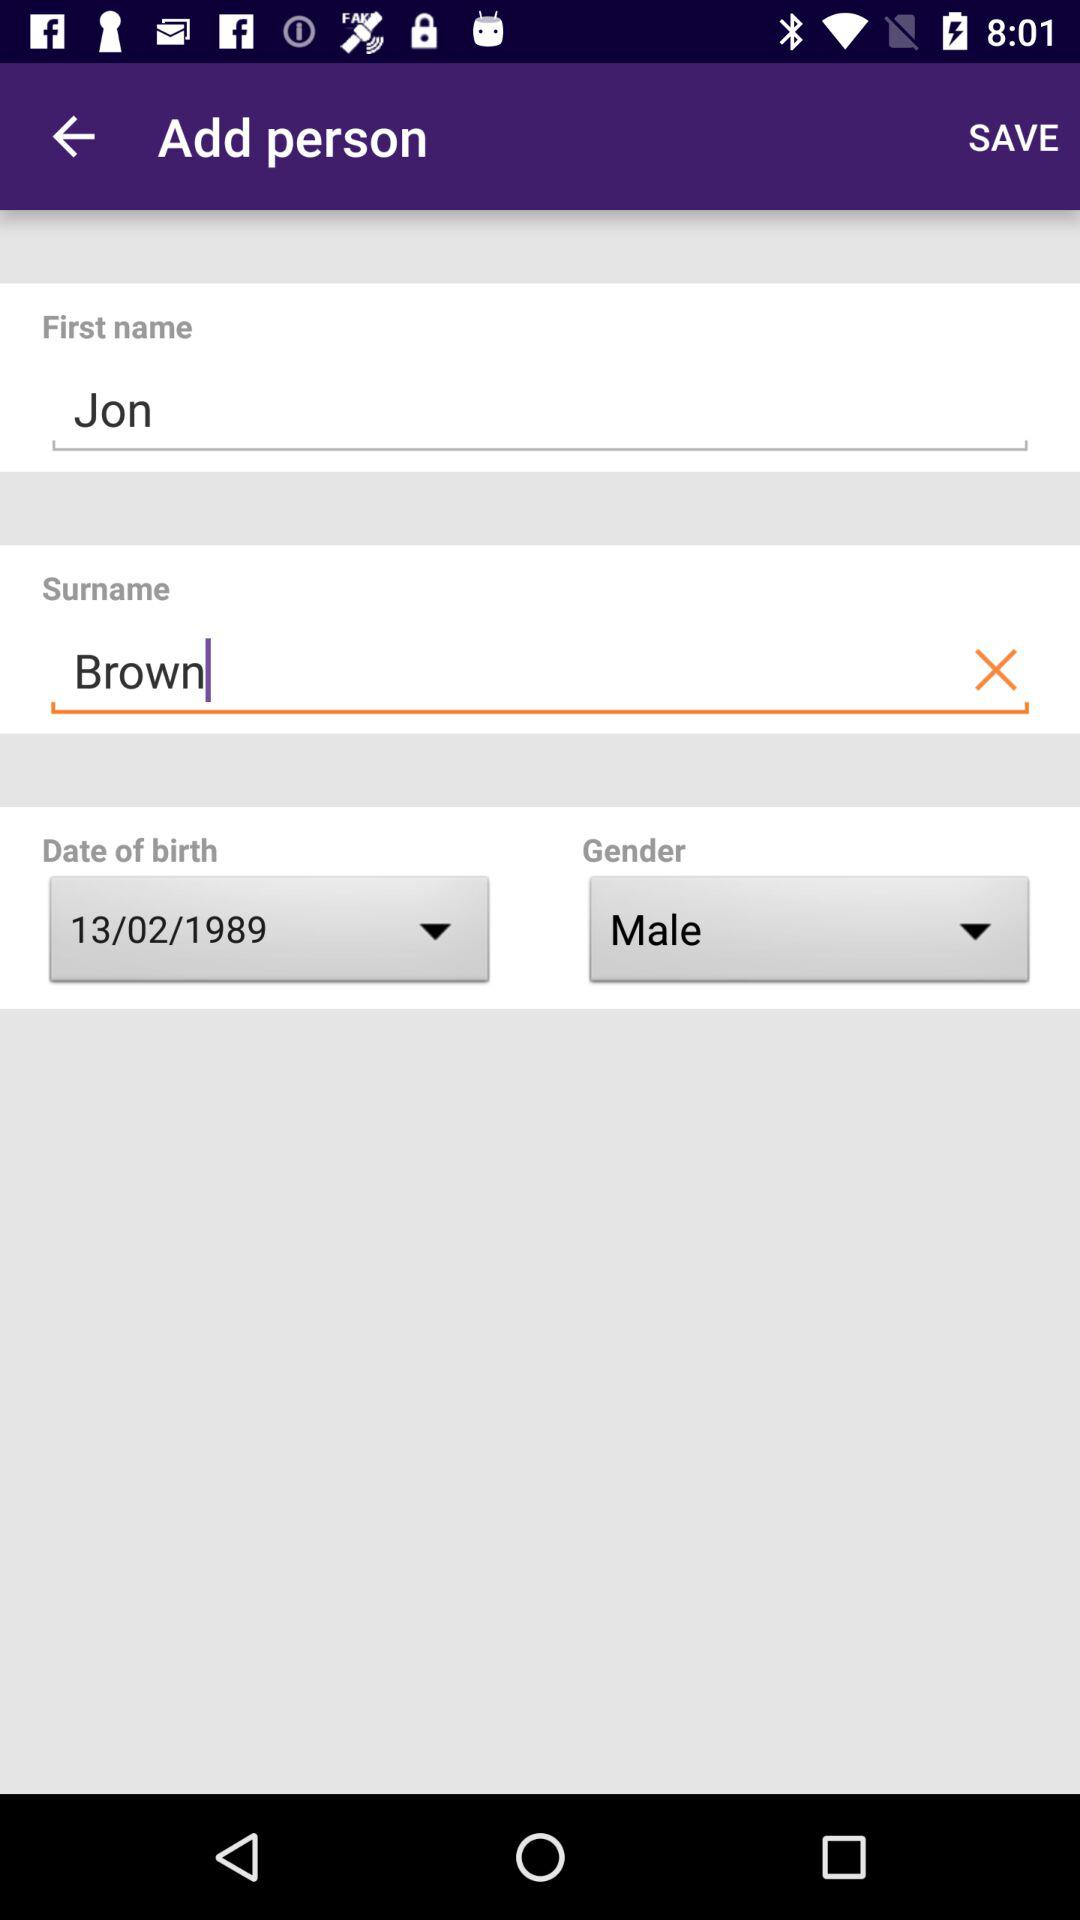What is the first name? The first name is Jon. 